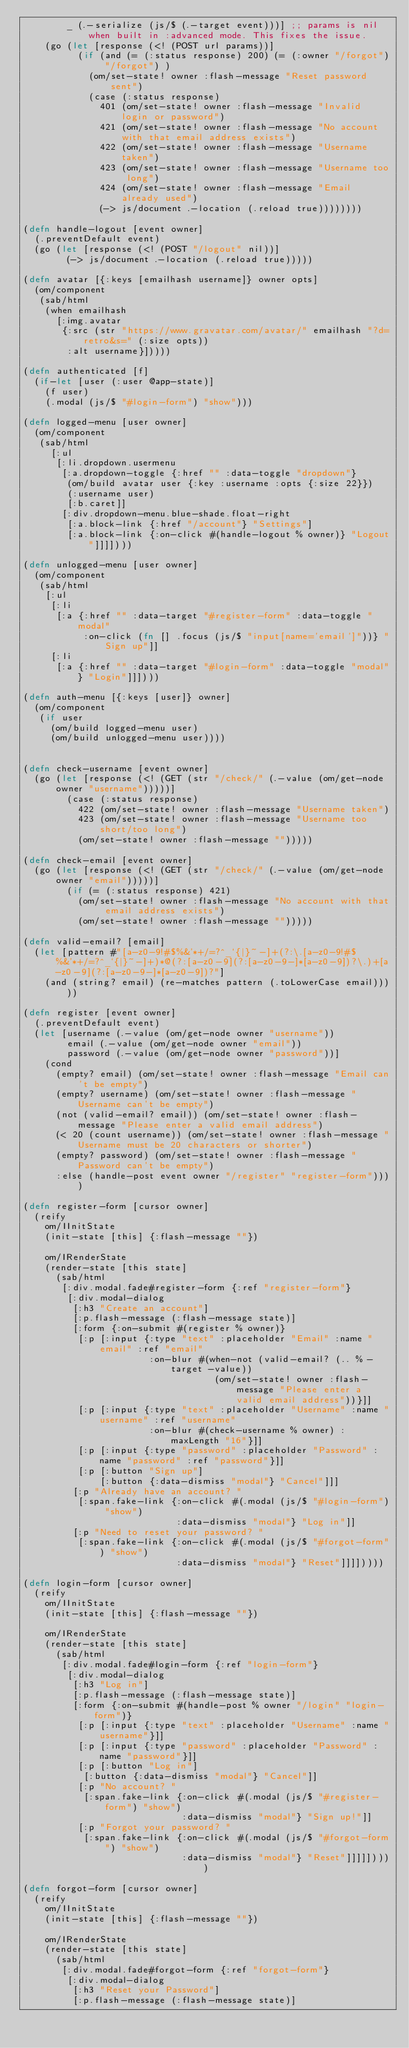<code> <loc_0><loc_0><loc_500><loc_500><_Clojure_>        _ (.-serialize (js/$ (.-target event)))] ;; params is nil when built in :advanced mode. This fixes the issue.
    (go (let [response (<! (POST url params))]
          (if (and (= (:status response) 200) (= (:owner "/forgot") "/forgot") )
            (om/set-state! owner :flash-message "Reset password sent")
            (case (:status response)
              401 (om/set-state! owner :flash-message "Invalid login or password")
              421 (om/set-state! owner :flash-message "No account with that email address exists")
              422 (om/set-state! owner :flash-message "Username taken")
              423 (om/set-state! owner :flash-message "Username too long")
              424 (om/set-state! owner :flash-message "Email already used")
              (-> js/document .-location (.reload true))))))))

(defn handle-logout [event owner]
  (.preventDefault event)
  (go (let [response (<! (POST "/logout" nil))]
        (-> js/document .-location (.reload true)))))

(defn avatar [{:keys [emailhash username]} owner opts]
  (om/component
   (sab/html
    (when emailhash
      [:img.avatar
       {:src (str "https://www.gravatar.com/avatar/" emailhash "?d=retro&s=" (:size opts))
        :alt username}]))))

(defn authenticated [f]
  (if-let [user (:user @app-state)]
    (f user)
    (.modal (js/$ "#login-form") "show")))

(defn logged-menu [user owner]
  (om/component
   (sab/html
     [:ul
      [:li.dropdown.usermenu
       [:a.dropdown-toggle {:href "" :data-toggle "dropdown"}
        (om/build avatar user {:key :username :opts {:size 22}})
        (:username user)
        [:b.caret]]
       [:div.dropdown-menu.blue-shade.float-right
        [:a.block-link {:href "/account"} "Settings"]
        [:a.block-link {:on-click #(handle-logout % owner)} "Logout"]]]])))

(defn unlogged-menu [user owner]
  (om/component
   (sab/html
    [:ul
     [:li
      [:a {:href "" :data-target "#register-form" :data-toggle "modal"
           :on-click (fn [] .focus (js/$ "input[name='email']"))} "Sign up"]]
     [:li
      [:a {:href "" :data-target "#login-form" :data-toggle "modal"} "Login"]]])))

(defn auth-menu [{:keys [user]} owner]
  (om/component
   (if user
     (om/build logged-menu user)
     (om/build unlogged-menu user))))


(defn check-username [event owner]
  (go (let [response (<! (GET (str "/check/" (.-value (om/get-node owner "username")))))]
        (case (:status response)
          422 (om/set-state! owner :flash-message "Username taken")
          423 (om/set-state! owner :flash-message "Username too short/too long")
          (om/set-state! owner :flash-message "")))))

(defn check-email [event owner]
  (go (let [response (<! (GET (str "/check/" (.-value (om/get-node owner "email")))))]
        (if (= (:status response) 421)
          (om/set-state! owner :flash-message "No account with that email address exists")
          (om/set-state! owner :flash-message "")))))

(defn valid-email? [email]
  (let [pattern #"[a-z0-9!#$%&'*+/=?^_`{|}~-]+(?:\.[a-z0-9!#$%&'*+/=?^_`{|}~-]+)*@(?:[a-z0-9](?:[a-z0-9-]*[a-z0-9])?\.)+[a-z0-9](?:[a-z0-9-]*[a-z0-9])?"]
    (and (string? email) (re-matches pattern (.toLowerCase email)))))

(defn register [event owner]
  (.preventDefault event)
  (let [username (.-value (om/get-node owner "username"))
        email (.-value (om/get-node owner "email"))
        password (.-value (om/get-node owner "password"))]
    (cond
      (empty? email) (om/set-state! owner :flash-message "Email can't be empty")
      (empty? username) (om/set-state! owner :flash-message "Username can't be empty")
      (not (valid-email? email)) (om/set-state! owner :flash-message "Please enter a valid email address")
      (< 20 (count username)) (om/set-state! owner :flash-message "Username must be 20 characters or shorter")
      (empty? password) (om/set-state! owner :flash-message "Password can't be empty")
      :else (handle-post event owner "/register" "register-form"))))

(defn register-form [cursor owner]
  (reify
    om/IInitState
    (init-state [this] {:flash-message ""})

    om/IRenderState
    (render-state [this state]
      (sab/html
       [:div.modal.fade#register-form {:ref "register-form"}
        [:div.modal-dialog
         [:h3 "Create an account"]
         [:p.flash-message (:flash-message state)]
         [:form {:on-submit #(register % owner)}
          [:p [:input {:type "text" :placeholder "Email" :name "email" :ref "email"
                       :on-blur #(when-not (valid-email? (.. % -target -value))
                                   (om/set-state! owner :flash-message "Please enter a valid email address"))}]]
          [:p [:input {:type "text" :placeholder "Username" :name "username" :ref "username"
                       :on-blur #(check-username % owner) :maxLength "16"}]]
          [:p [:input {:type "password" :placeholder "Password" :name "password" :ref "password"}]]
          [:p [:button "Sign up"]
              [:button {:data-dismiss "modal"} "Cancel"]]]
         [:p "Already have an account? "
          [:span.fake-link {:on-click #(.modal (js/$ "#login-form") "show")
                            :data-dismiss "modal"} "Log in"]]
         [:p "Need to reset your password? "
          [:span.fake-link {:on-click #(.modal (js/$ "#forgot-form") "show")
                            :data-dismiss "modal"} "Reset"]]]]))))

(defn login-form [cursor owner]
  (reify
    om/IInitState
    (init-state [this] {:flash-message ""})

    om/IRenderState
    (render-state [this state]
      (sab/html
       [:div.modal.fade#login-form {:ref "login-form"}
        [:div.modal-dialog
         [:h3 "Log in"]
         [:p.flash-message (:flash-message state)]
         [:form {:on-submit #(handle-post % owner "/login" "login-form")}
          [:p [:input {:type "text" :placeholder "Username" :name "username"}]]
          [:p [:input {:type "password" :placeholder "Password" :name "password"}]]
          [:p [:button "Log in"]
           [:button {:data-dismiss "modal"} "Cancel"]]
          [:p "No account? "
           [:span.fake-link {:on-click #(.modal (js/$ "#register-form") "show")
                             :data-dismiss "modal"} "Sign up!"]]
          [:p "Forgot your password? "
           [:span.fake-link {:on-click #(.modal (js/$ "#forgot-form") "show")
                             :data-dismiss "modal"} "Reset"]]]]]))))

(defn forgot-form [cursor owner]
  (reify
    om/IInitState
    (init-state [this] {:flash-message ""})

    om/IRenderState
    (render-state [this state]
      (sab/html
       [:div.modal.fade#forgot-form {:ref "forgot-form"}
        [:div.modal-dialog
         [:h3 "Reset your Password"]
         [:p.flash-message (:flash-message state)]</code> 